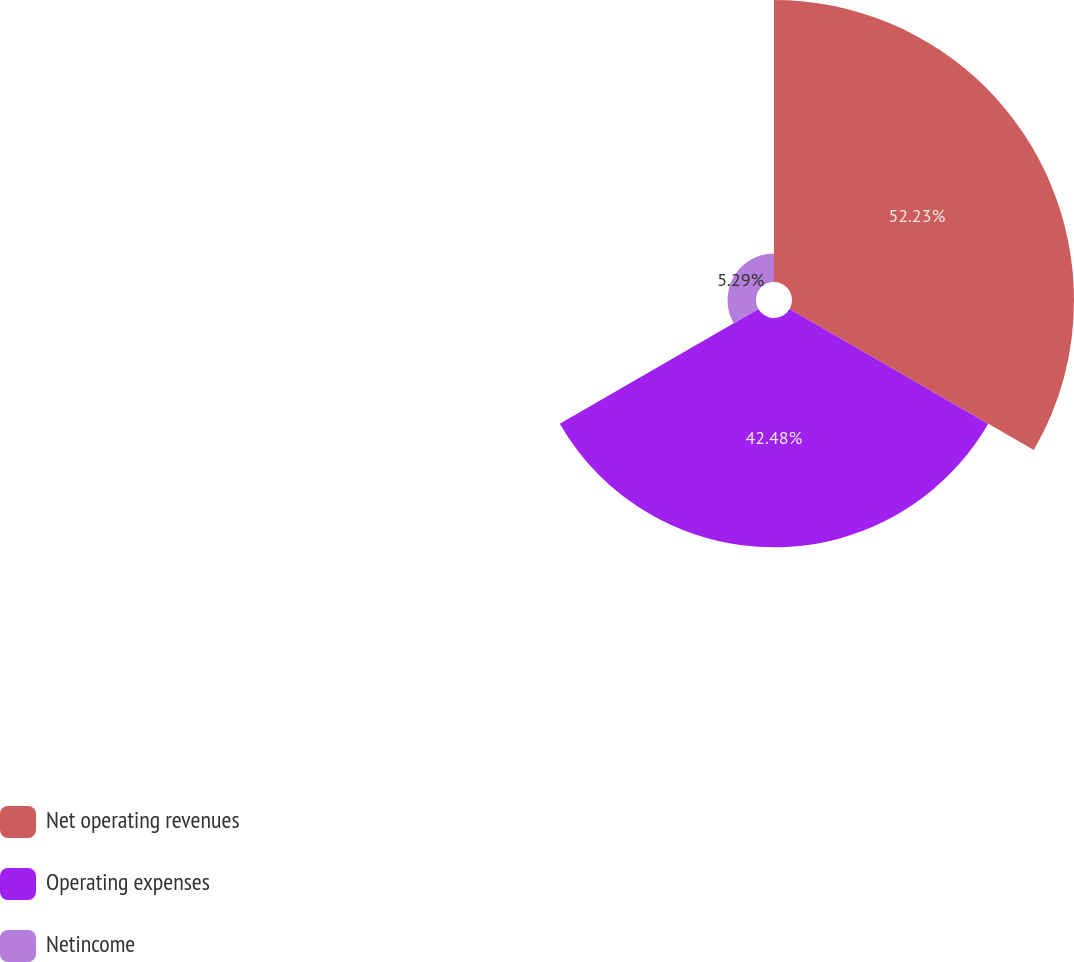Convert chart to OTSL. <chart><loc_0><loc_0><loc_500><loc_500><pie_chart><fcel>Net operating revenues<fcel>Operating expenses<fcel>Netincome<nl><fcel>52.23%<fcel>42.48%<fcel>5.29%<nl></chart> 